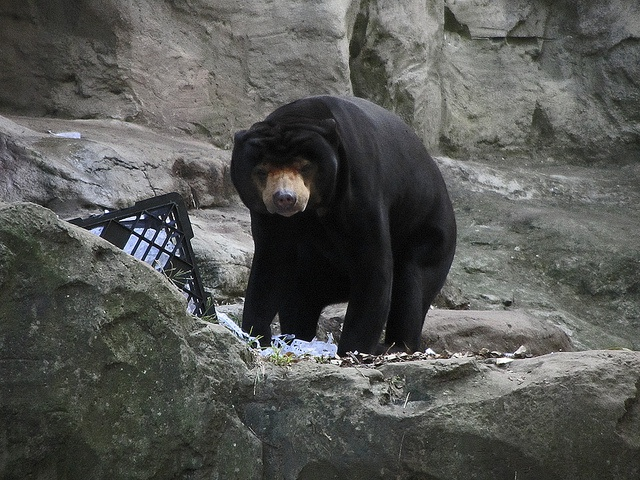Describe the objects in this image and their specific colors. I can see a bear in black, gray, and darkgray tones in this image. 